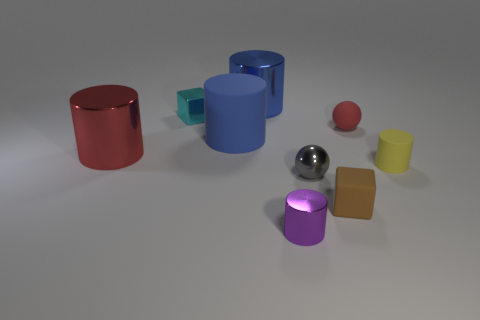What colors are the cubes in this image? The cubes in the image are blue, yellow, and brown. There is also a smaller cube that appears to be a light teal or turquoise color. 